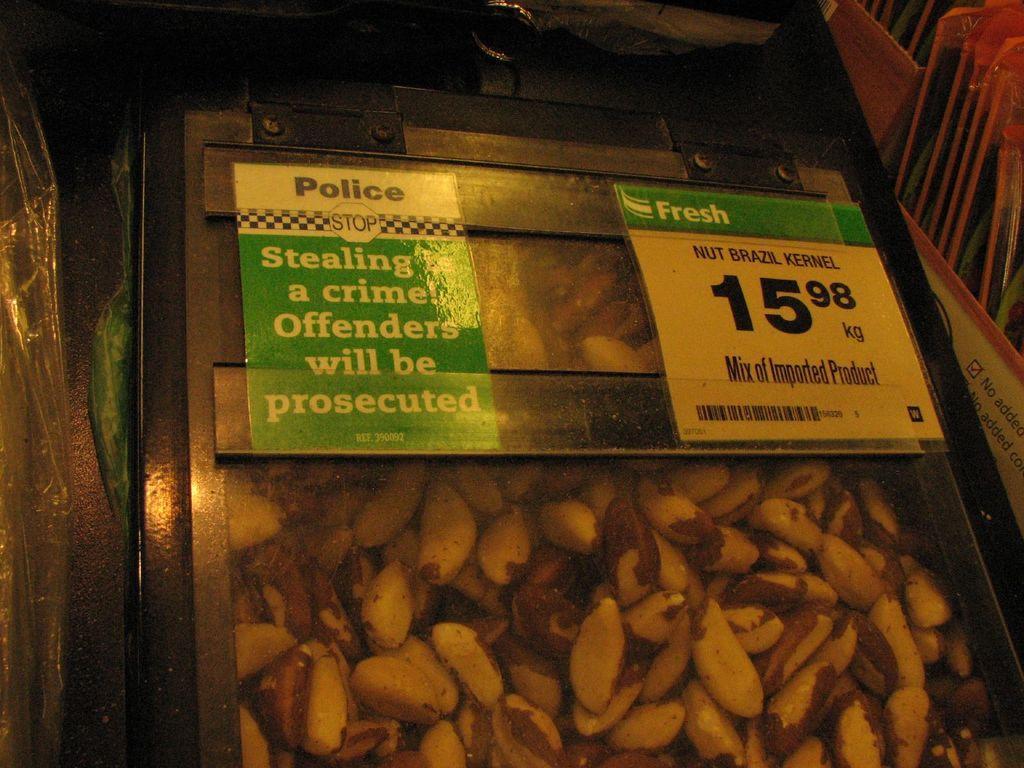Describe this image in one or two sentences. In this picture we can see some nut Brazil kernels here, there are two papers pasted on this box. 